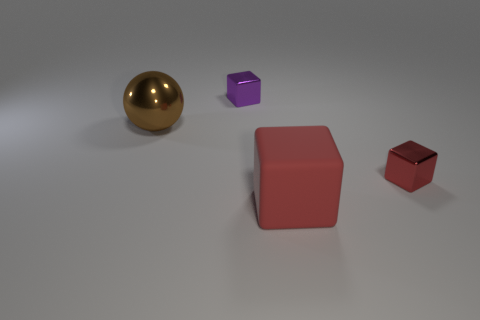Add 4 small purple shiny blocks. How many objects exist? 8 Subtract all cubes. How many objects are left? 1 Subtract 0 cyan cylinders. How many objects are left? 4 Subtract all big brown shiny cylinders. Subtract all large red rubber cubes. How many objects are left? 3 Add 4 red blocks. How many red blocks are left? 6 Add 3 red rubber objects. How many red rubber objects exist? 4 